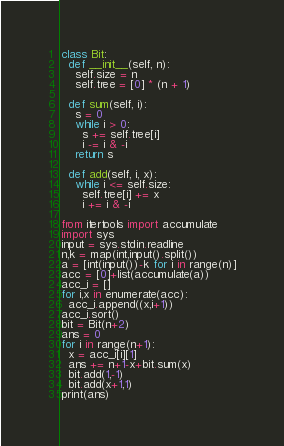<code> <loc_0><loc_0><loc_500><loc_500><_Python_>class Bit:
  def __init__(self, n):
    self.size = n
    self.tree = [0] * (n + 1)
 
  def sum(self, i):
    s = 0
    while i > 0:
      s += self.tree[i]
      i -= i & -i
    return s

  def add(self, i, x):
    while i <= self.size:
      self.tree[i] += x
      i += i & -i

from itertools import accumulate
import sys
input = sys.stdin.readline
n,k = map(int,input().split())
a = [int(input())-k for i in range(n)]
acc = [0]+list(accumulate(a))
acc_i = []
for i,x in enumerate(acc):
  acc_i.append((x,i+1))
acc_i.sort()
bit = Bit(n+2)
ans = 0
for i in range(n+1):
  x = acc_i[i][1]
  ans += n+1-x+bit.sum(x)
  bit.add(1,-1)
  bit.add(x+1,1)
print(ans)</code> 